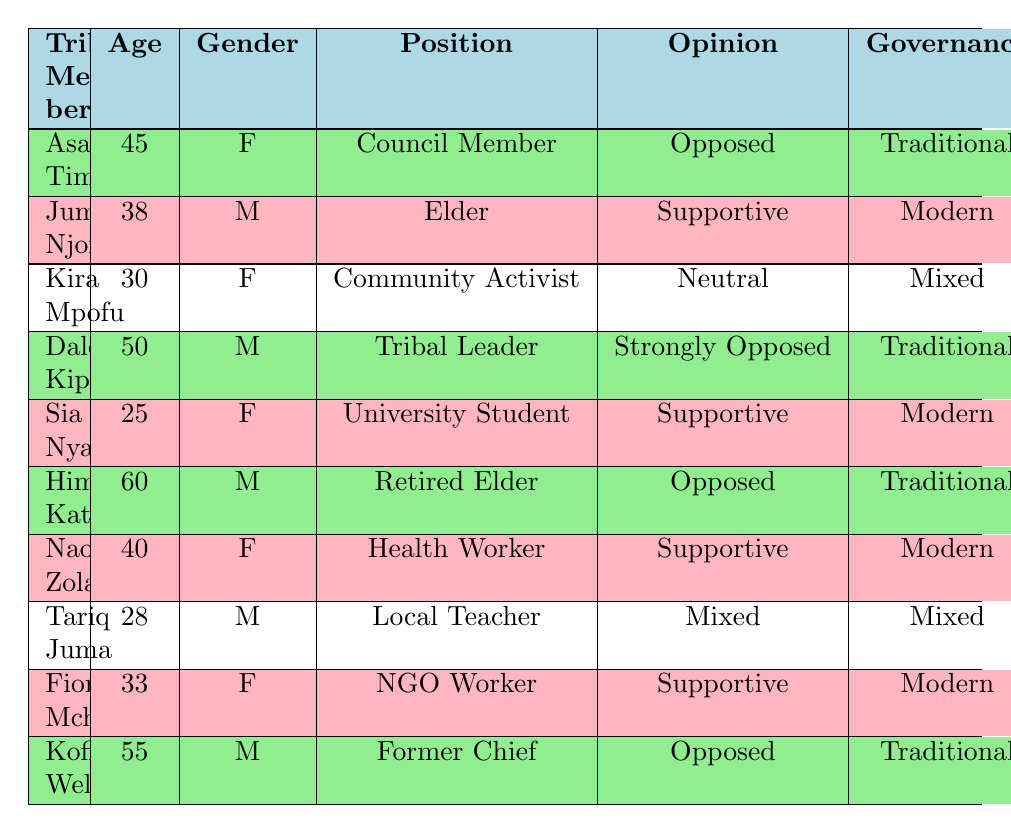What is the age of Asa Tima? The table lists Asa Tima with an age of 45. Thus, the answer is simply retrieved from the 'Age' column corresponding to Asa Tima.
Answer: 45 How many tribal members oppose modern governance? To find the total number of members that oppose modern governance, I look for entries that state "Opposed" or "Strongly Opposed" in the 'Opinion' column. The members Asa Tima, Himaya Kato, Dalo Kipanga, and Kofi Weld fit this description, making a total of 4 members.
Answer: 4 What is the preferred governance of the community activist? The row for Kira Mpofu contains "Mixed" under the 'Preferred Governance' column. Therefore, the preferred governance for the community activist is determined directly from this entry.
Answer: Mixed Do more female members support modern governance than male members? I will count supportive answers for each gender. From the table, female supporters (Sia Nyanga, Naomi Zola, Fiona Mchango) total 3. Male supporters (Juma Njoroge) total 1. Since 3 is greater than 1, more female members support modern governance.
Answer: Yes What is the average age of members who prefer traditional governance? I will first identify the ages of members preferring traditional governance: Asa Tima (45), Dalo Kipanga (50), Himaya Kato (60), and Kofi Weld (55). Adding these gives 210 years. To find the average, divide 210 by the 4 members, which results in an average age of 52.5.
Answer: 52.5 How many members express a neutral opinion towards the government? By scanning the 'Opinion' column, the entry for Kira Mpofu explicitly states "Neutral". Since this is the only record indicating neutrality, the total count is 1.
Answer: 1 What is the reason for Dalo Kipanga's strong opposition to modern governance? Looking at the row for Dalo Kipanga, it states the reason as "Fear of losing power to external influences". This statement provides the exact reasoning for his opinion as found in the 'Reason' column.
Answer: Fear of losing power to external influences Which tribal member believes in improving economic opportunities? The entry for Juma Njoroge in the 'Reason' column states "Believes in improving economic opportunities". This directly answers which member holds this belief.
Answer: Juma Njoroge Are there any members with a supporting opinion who prefer mixed governance? It is noted that Tariq Juma, who has a "Mixed" preference in the 'Preferred Governance' column, declares a "Mixed" opinion. Hence, there is one member with this characteristic.
Answer: Yes 